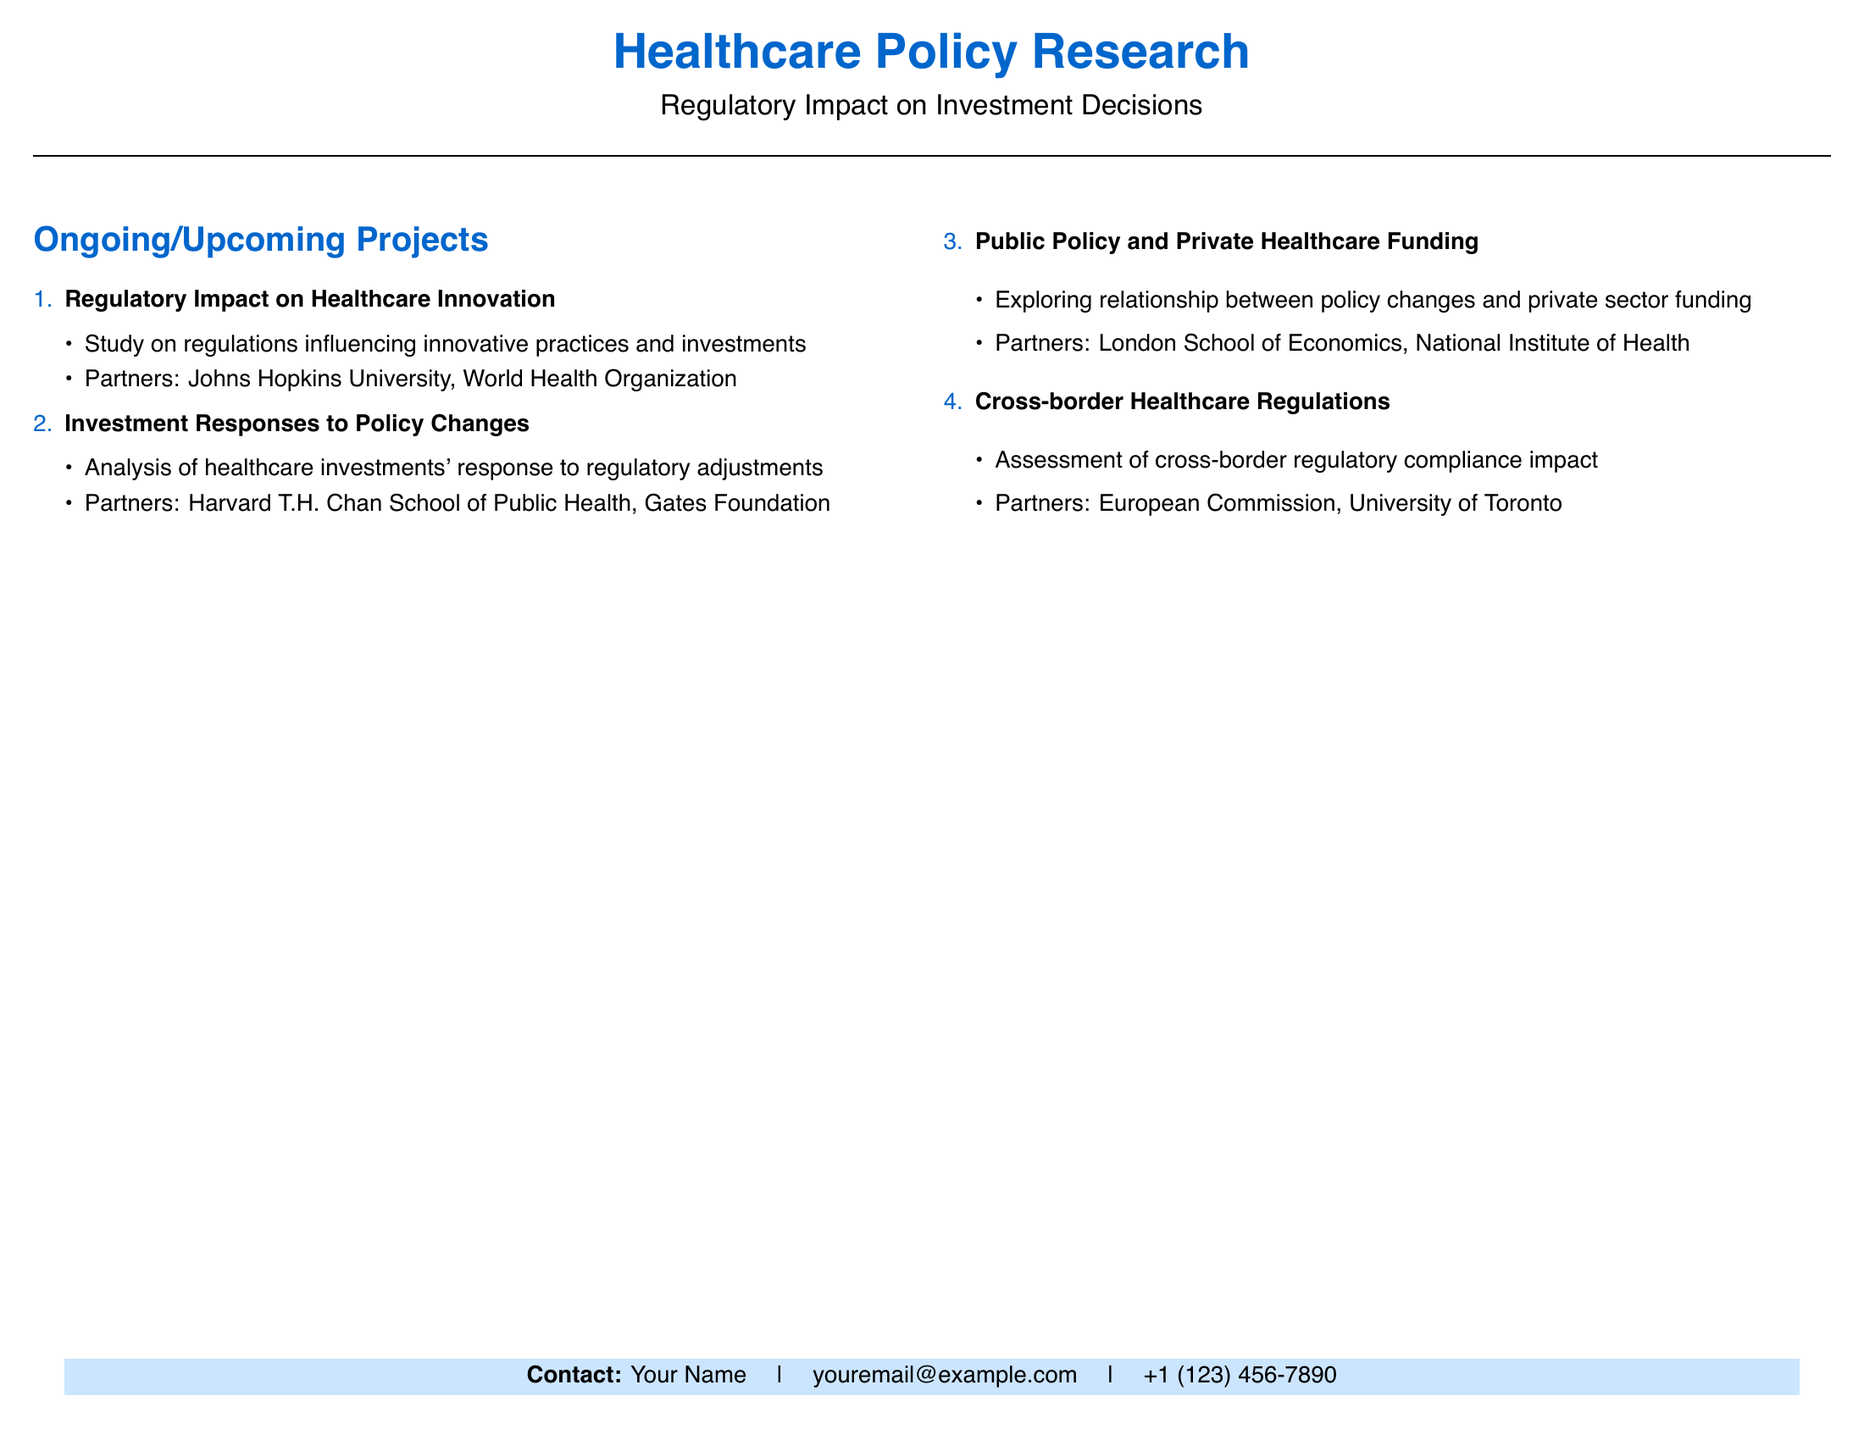What is the main focus of the document? The document is centered around healthcare policy research, specifically regulatory impact on investment decisions.
Answer: Regulatory Impact on Investment Decisions How many ongoing/upcoming projects are listed? The document enumerates several ongoing and upcoming research projects pertaining to healthcare policy.
Answer: 4 What organization partners with Johns Hopkins University? The document lists Johns Hopkins University as a partner in the project concerning regulatory impact on healthcare innovation.
Answer: World Health Organization Which project analyzes healthcare investments' response to regulatory adjustments? This project focuses on dissecting healthcare investments in relation to policy alterations, reflecting its main inquiry.
Answer: Investment Responses to Policy Changes What is the title of the project that explores the relationship between policy changes and private sector funding? The document specifies this project with a title that directly relates to private healthcare financing dynamics in context to policy.
Answer: Public Policy and Private Healthcare Funding Which two organizations are involved in cross-border healthcare regulations? The document mentions collaborative efforts across boundaries concerning healthcare compliance and specific organizations engaged in this initiative.
Answer: European Commission, University of Toronto What type of analysis does the investment responses project involve? This project requires a thorough examination of how investments in healthcare react to modifications in regulatory frameworks.
Answer: Analysis Who is the contact person listed in the document? The contact area of the document identifies an individual responsible for inquiries related to the research.
Answer: Your Name 